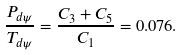<formula> <loc_0><loc_0><loc_500><loc_500>\frac { P _ { d \psi } } { T _ { d \psi } } = \frac { C _ { 3 } + C _ { 5 } } { C _ { 1 } } = 0 . 0 7 6 .</formula> 